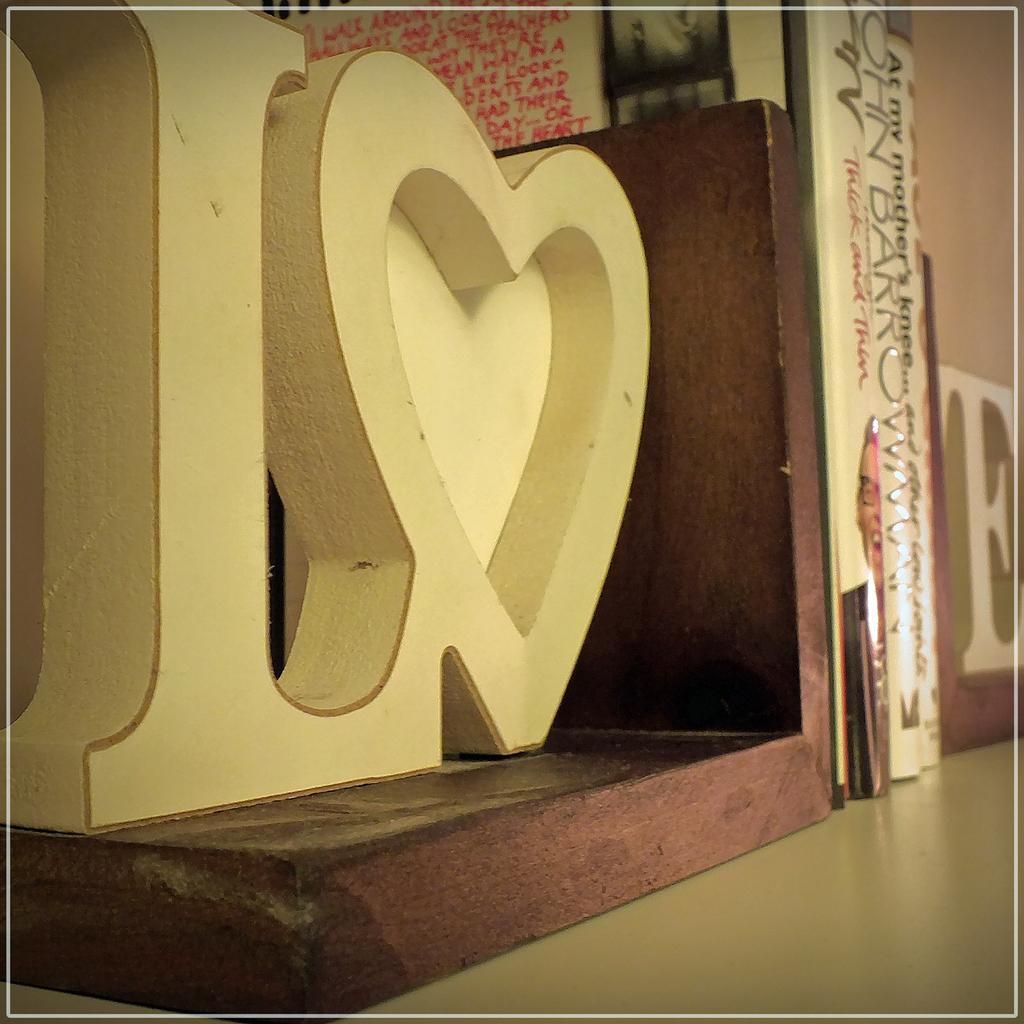Provide a one-sentence caption for the provided image. the bookends holding a few books on a shelf spell LOVE. 